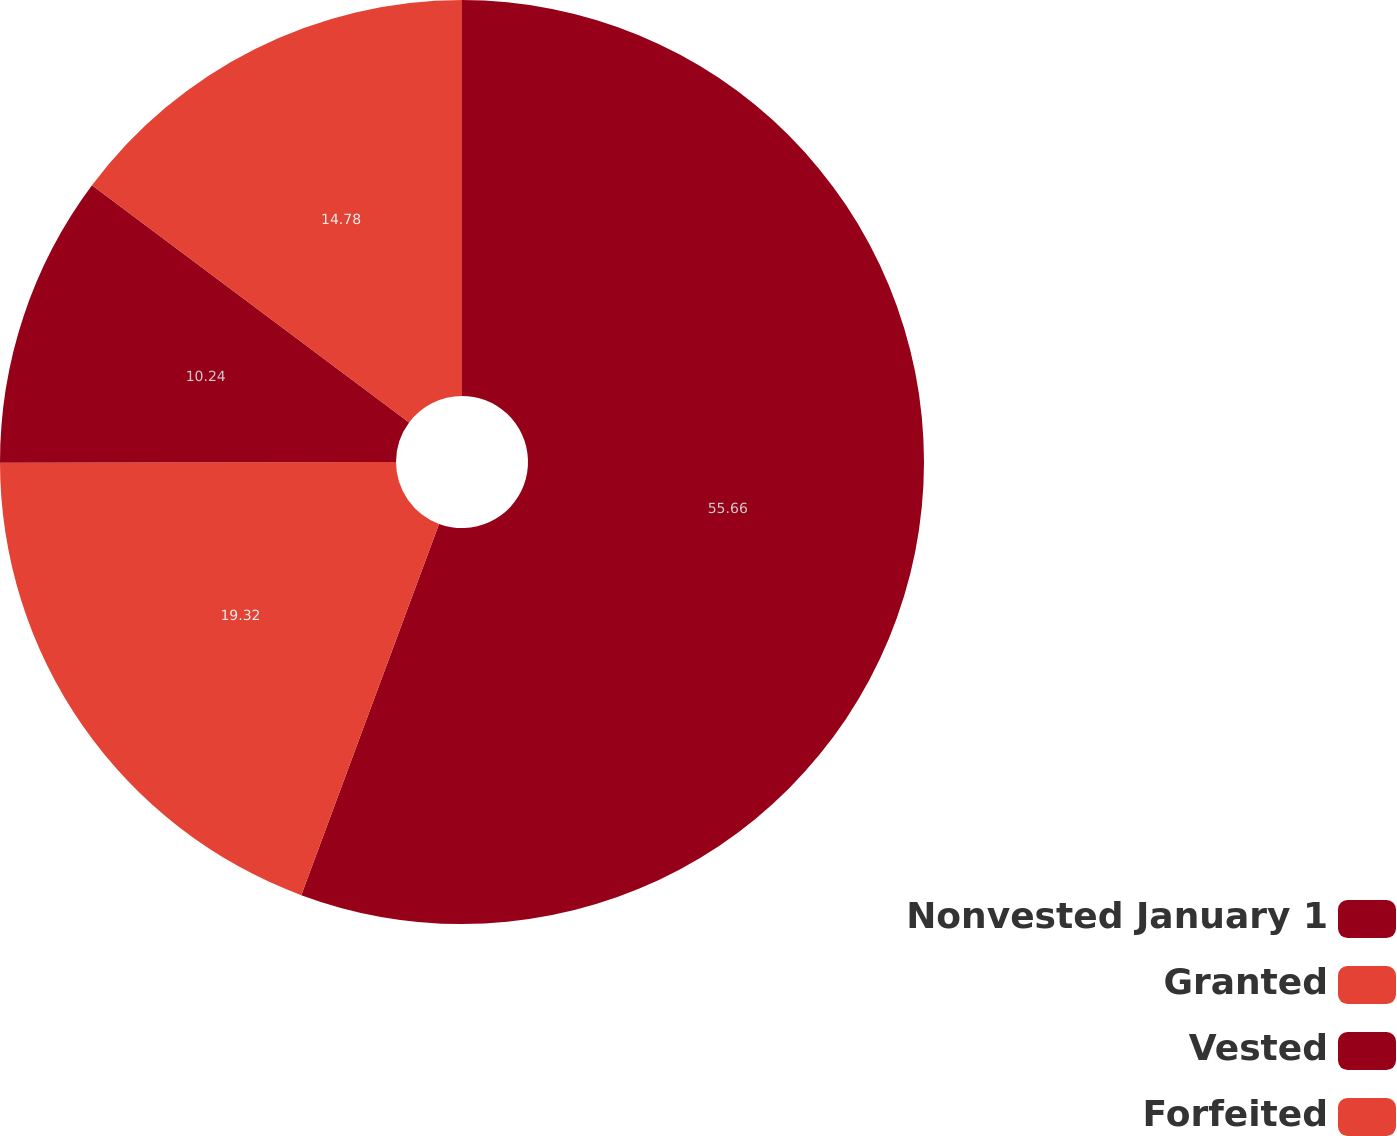Convert chart. <chart><loc_0><loc_0><loc_500><loc_500><pie_chart><fcel>Nonvested January 1<fcel>Granted<fcel>Vested<fcel>Forfeited<nl><fcel>55.65%<fcel>19.32%<fcel>10.24%<fcel>14.78%<nl></chart> 